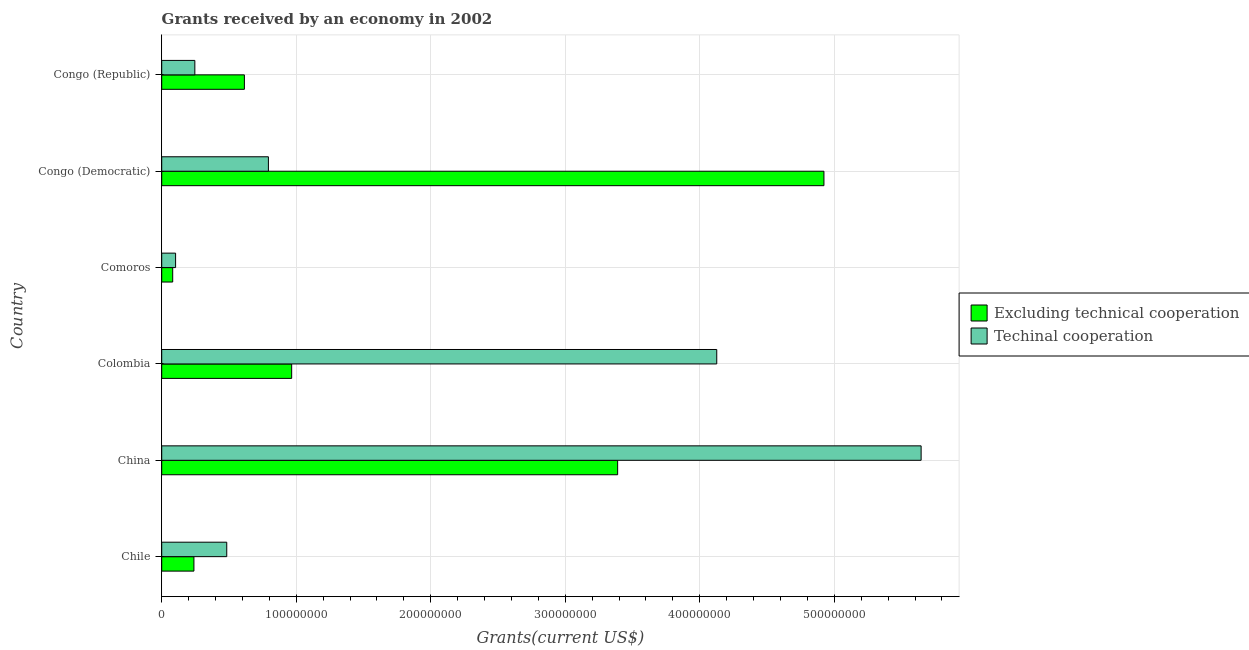How many different coloured bars are there?
Provide a succinct answer. 2. How many bars are there on the 4th tick from the bottom?
Provide a succinct answer. 2. What is the label of the 2nd group of bars from the top?
Make the answer very short. Congo (Democratic). In how many cases, is the number of bars for a given country not equal to the number of legend labels?
Provide a succinct answer. 0. What is the amount of grants received(including technical cooperation) in Congo (Democratic)?
Keep it short and to the point. 7.93e+07. Across all countries, what is the maximum amount of grants received(excluding technical cooperation)?
Your response must be concise. 4.92e+08. Across all countries, what is the minimum amount of grants received(excluding technical cooperation)?
Provide a short and direct response. 8.17e+06. In which country was the amount of grants received(excluding technical cooperation) maximum?
Your answer should be very brief. Congo (Democratic). In which country was the amount of grants received(excluding technical cooperation) minimum?
Offer a terse response. Comoros. What is the total amount of grants received(including technical cooperation) in the graph?
Ensure brevity in your answer.  1.14e+09. What is the difference between the amount of grants received(excluding technical cooperation) in China and that in Colombia?
Offer a terse response. 2.42e+08. What is the difference between the amount of grants received(excluding technical cooperation) in Congo (Democratic) and the amount of grants received(including technical cooperation) in Comoros?
Provide a succinct answer. 4.82e+08. What is the average amount of grants received(including technical cooperation) per country?
Your answer should be very brief. 1.90e+08. What is the difference between the amount of grants received(including technical cooperation) and amount of grants received(excluding technical cooperation) in Chile?
Your answer should be very brief. 2.44e+07. In how many countries, is the amount of grants received(including technical cooperation) greater than 100000000 US$?
Offer a terse response. 2. What is the ratio of the amount of grants received(excluding technical cooperation) in Chile to that in China?
Make the answer very short. 0.07. What is the difference between the highest and the second highest amount of grants received(excluding technical cooperation)?
Keep it short and to the point. 1.53e+08. What is the difference between the highest and the lowest amount of grants received(excluding technical cooperation)?
Keep it short and to the point. 4.84e+08. In how many countries, is the amount of grants received(excluding technical cooperation) greater than the average amount of grants received(excluding technical cooperation) taken over all countries?
Make the answer very short. 2. Is the sum of the amount of grants received(excluding technical cooperation) in Chile and Comoros greater than the maximum amount of grants received(including technical cooperation) across all countries?
Provide a short and direct response. No. What does the 2nd bar from the top in Chile represents?
Provide a succinct answer. Excluding technical cooperation. What does the 1st bar from the bottom in Congo (Democratic) represents?
Keep it short and to the point. Excluding technical cooperation. How many bars are there?
Ensure brevity in your answer.  12. Are all the bars in the graph horizontal?
Your answer should be very brief. Yes. How many countries are there in the graph?
Offer a very short reply. 6. What is the difference between two consecutive major ticks on the X-axis?
Offer a very short reply. 1.00e+08. Does the graph contain grids?
Offer a very short reply. Yes. How are the legend labels stacked?
Your answer should be very brief. Vertical. What is the title of the graph?
Make the answer very short. Grants received by an economy in 2002. What is the label or title of the X-axis?
Your answer should be very brief. Grants(current US$). What is the Grants(current US$) of Excluding technical cooperation in Chile?
Give a very brief answer. 2.40e+07. What is the Grants(current US$) of Techinal cooperation in Chile?
Offer a very short reply. 4.84e+07. What is the Grants(current US$) in Excluding technical cooperation in China?
Ensure brevity in your answer.  3.39e+08. What is the Grants(current US$) of Techinal cooperation in China?
Make the answer very short. 5.65e+08. What is the Grants(current US$) of Excluding technical cooperation in Colombia?
Your answer should be compact. 9.66e+07. What is the Grants(current US$) in Techinal cooperation in Colombia?
Offer a terse response. 4.13e+08. What is the Grants(current US$) in Excluding technical cooperation in Comoros?
Your answer should be compact. 8.17e+06. What is the Grants(current US$) of Techinal cooperation in Comoros?
Give a very brief answer. 1.03e+07. What is the Grants(current US$) in Excluding technical cooperation in Congo (Democratic)?
Offer a very short reply. 4.92e+08. What is the Grants(current US$) in Techinal cooperation in Congo (Democratic)?
Provide a succinct answer. 7.93e+07. What is the Grants(current US$) of Excluding technical cooperation in Congo (Republic)?
Provide a short and direct response. 6.15e+07. What is the Grants(current US$) of Techinal cooperation in Congo (Republic)?
Offer a terse response. 2.46e+07. Across all countries, what is the maximum Grants(current US$) in Excluding technical cooperation?
Provide a short and direct response. 4.92e+08. Across all countries, what is the maximum Grants(current US$) of Techinal cooperation?
Your answer should be very brief. 5.65e+08. Across all countries, what is the minimum Grants(current US$) of Excluding technical cooperation?
Ensure brevity in your answer.  8.17e+06. Across all countries, what is the minimum Grants(current US$) of Techinal cooperation?
Your answer should be compact. 1.03e+07. What is the total Grants(current US$) in Excluding technical cooperation in the graph?
Keep it short and to the point. 1.02e+09. What is the total Grants(current US$) in Techinal cooperation in the graph?
Your response must be concise. 1.14e+09. What is the difference between the Grants(current US$) in Excluding technical cooperation in Chile and that in China?
Give a very brief answer. -3.15e+08. What is the difference between the Grants(current US$) of Techinal cooperation in Chile and that in China?
Your response must be concise. -5.16e+08. What is the difference between the Grants(current US$) of Excluding technical cooperation in Chile and that in Colombia?
Your answer should be compact. -7.27e+07. What is the difference between the Grants(current US$) in Techinal cooperation in Chile and that in Colombia?
Provide a short and direct response. -3.64e+08. What is the difference between the Grants(current US$) in Excluding technical cooperation in Chile and that in Comoros?
Your answer should be very brief. 1.58e+07. What is the difference between the Grants(current US$) of Techinal cooperation in Chile and that in Comoros?
Offer a terse response. 3.80e+07. What is the difference between the Grants(current US$) in Excluding technical cooperation in Chile and that in Congo (Democratic)?
Give a very brief answer. -4.68e+08. What is the difference between the Grants(current US$) of Techinal cooperation in Chile and that in Congo (Democratic)?
Your answer should be very brief. -3.10e+07. What is the difference between the Grants(current US$) in Excluding technical cooperation in Chile and that in Congo (Republic)?
Your response must be concise. -3.75e+07. What is the difference between the Grants(current US$) in Techinal cooperation in Chile and that in Congo (Republic)?
Your answer should be very brief. 2.37e+07. What is the difference between the Grants(current US$) of Excluding technical cooperation in China and that in Colombia?
Your response must be concise. 2.42e+08. What is the difference between the Grants(current US$) in Techinal cooperation in China and that in Colombia?
Offer a terse response. 1.52e+08. What is the difference between the Grants(current US$) of Excluding technical cooperation in China and that in Comoros?
Offer a terse response. 3.31e+08. What is the difference between the Grants(current US$) in Techinal cooperation in China and that in Comoros?
Provide a short and direct response. 5.54e+08. What is the difference between the Grants(current US$) of Excluding technical cooperation in China and that in Congo (Democratic)?
Provide a short and direct response. -1.53e+08. What is the difference between the Grants(current US$) in Techinal cooperation in China and that in Congo (Democratic)?
Offer a terse response. 4.85e+08. What is the difference between the Grants(current US$) in Excluding technical cooperation in China and that in Congo (Republic)?
Keep it short and to the point. 2.77e+08. What is the difference between the Grants(current US$) in Techinal cooperation in China and that in Congo (Republic)?
Your answer should be compact. 5.40e+08. What is the difference between the Grants(current US$) of Excluding technical cooperation in Colombia and that in Comoros?
Your response must be concise. 8.84e+07. What is the difference between the Grants(current US$) of Techinal cooperation in Colombia and that in Comoros?
Keep it short and to the point. 4.02e+08. What is the difference between the Grants(current US$) in Excluding technical cooperation in Colombia and that in Congo (Democratic)?
Offer a terse response. -3.96e+08. What is the difference between the Grants(current US$) of Techinal cooperation in Colombia and that in Congo (Democratic)?
Provide a short and direct response. 3.33e+08. What is the difference between the Grants(current US$) in Excluding technical cooperation in Colombia and that in Congo (Republic)?
Provide a succinct answer. 3.52e+07. What is the difference between the Grants(current US$) in Techinal cooperation in Colombia and that in Congo (Republic)?
Your answer should be very brief. 3.88e+08. What is the difference between the Grants(current US$) of Excluding technical cooperation in Comoros and that in Congo (Democratic)?
Ensure brevity in your answer.  -4.84e+08. What is the difference between the Grants(current US$) in Techinal cooperation in Comoros and that in Congo (Democratic)?
Make the answer very short. -6.90e+07. What is the difference between the Grants(current US$) of Excluding technical cooperation in Comoros and that in Congo (Republic)?
Your response must be concise. -5.33e+07. What is the difference between the Grants(current US$) of Techinal cooperation in Comoros and that in Congo (Republic)?
Ensure brevity in your answer.  -1.43e+07. What is the difference between the Grants(current US$) of Excluding technical cooperation in Congo (Democratic) and that in Congo (Republic)?
Your answer should be compact. 4.31e+08. What is the difference between the Grants(current US$) in Techinal cooperation in Congo (Democratic) and that in Congo (Republic)?
Give a very brief answer. 5.47e+07. What is the difference between the Grants(current US$) in Excluding technical cooperation in Chile and the Grants(current US$) in Techinal cooperation in China?
Offer a terse response. -5.41e+08. What is the difference between the Grants(current US$) in Excluding technical cooperation in Chile and the Grants(current US$) in Techinal cooperation in Colombia?
Offer a very short reply. -3.89e+08. What is the difference between the Grants(current US$) of Excluding technical cooperation in Chile and the Grants(current US$) of Techinal cooperation in Comoros?
Your answer should be compact. 1.36e+07. What is the difference between the Grants(current US$) in Excluding technical cooperation in Chile and the Grants(current US$) in Techinal cooperation in Congo (Democratic)?
Provide a short and direct response. -5.54e+07. What is the difference between the Grants(current US$) in Excluding technical cooperation in Chile and the Grants(current US$) in Techinal cooperation in Congo (Republic)?
Give a very brief answer. -6.80e+05. What is the difference between the Grants(current US$) of Excluding technical cooperation in China and the Grants(current US$) of Techinal cooperation in Colombia?
Provide a succinct answer. -7.37e+07. What is the difference between the Grants(current US$) in Excluding technical cooperation in China and the Grants(current US$) in Techinal cooperation in Comoros?
Provide a succinct answer. 3.29e+08. What is the difference between the Grants(current US$) of Excluding technical cooperation in China and the Grants(current US$) of Techinal cooperation in Congo (Democratic)?
Offer a terse response. 2.60e+08. What is the difference between the Grants(current US$) of Excluding technical cooperation in China and the Grants(current US$) of Techinal cooperation in Congo (Republic)?
Your answer should be very brief. 3.14e+08. What is the difference between the Grants(current US$) in Excluding technical cooperation in Colombia and the Grants(current US$) in Techinal cooperation in Comoros?
Provide a short and direct response. 8.63e+07. What is the difference between the Grants(current US$) of Excluding technical cooperation in Colombia and the Grants(current US$) of Techinal cooperation in Congo (Democratic)?
Your response must be concise. 1.73e+07. What is the difference between the Grants(current US$) of Excluding technical cooperation in Colombia and the Grants(current US$) of Techinal cooperation in Congo (Republic)?
Give a very brief answer. 7.20e+07. What is the difference between the Grants(current US$) of Excluding technical cooperation in Comoros and the Grants(current US$) of Techinal cooperation in Congo (Democratic)?
Ensure brevity in your answer.  -7.11e+07. What is the difference between the Grants(current US$) in Excluding technical cooperation in Comoros and the Grants(current US$) in Techinal cooperation in Congo (Republic)?
Ensure brevity in your answer.  -1.65e+07. What is the difference between the Grants(current US$) of Excluding technical cooperation in Congo (Democratic) and the Grants(current US$) of Techinal cooperation in Congo (Republic)?
Your response must be concise. 4.68e+08. What is the average Grants(current US$) of Excluding technical cooperation per country?
Provide a short and direct response. 1.70e+08. What is the average Grants(current US$) of Techinal cooperation per country?
Keep it short and to the point. 1.90e+08. What is the difference between the Grants(current US$) in Excluding technical cooperation and Grants(current US$) in Techinal cooperation in Chile?
Your answer should be compact. -2.44e+07. What is the difference between the Grants(current US$) of Excluding technical cooperation and Grants(current US$) of Techinal cooperation in China?
Offer a very short reply. -2.26e+08. What is the difference between the Grants(current US$) of Excluding technical cooperation and Grants(current US$) of Techinal cooperation in Colombia?
Offer a terse response. -3.16e+08. What is the difference between the Grants(current US$) of Excluding technical cooperation and Grants(current US$) of Techinal cooperation in Comoros?
Offer a terse response. -2.15e+06. What is the difference between the Grants(current US$) in Excluding technical cooperation and Grants(current US$) in Techinal cooperation in Congo (Democratic)?
Your answer should be very brief. 4.13e+08. What is the difference between the Grants(current US$) in Excluding technical cooperation and Grants(current US$) in Techinal cooperation in Congo (Republic)?
Offer a very short reply. 3.68e+07. What is the ratio of the Grants(current US$) in Excluding technical cooperation in Chile to that in China?
Make the answer very short. 0.07. What is the ratio of the Grants(current US$) of Techinal cooperation in Chile to that in China?
Ensure brevity in your answer.  0.09. What is the ratio of the Grants(current US$) in Excluding technical cooperation in Chile to that in Colombia?
Ensure brevity in your answer.  0.25. What is the ratio of the Grants(current US$) in Techinal cooperation in Chile to that in Colombia?
Keep it short and to the point. 0.12. What is the ratio of the Grants(current US$) of Excluding technical cooperation in Chile to that in Comoros?
Offer a very short reply. 2.93. What is the ratio of the Grants(current US$) of Techinal cooperation in Chile to that in Comoros?
Give a very brief answer. 4.69. What is the ratio of the Grants(current US$) of Excluding technical cooperation in Chile to that in Congo (Democratic)?
Your response must be concise. 0.05. What is the ratio of the Grants(current US$) in Techinal cooperation in Chile to that in Congo (Democratic)?
Your answer should be very brief. 0.61. What is the ratio of the Grants(current US$) of Excluding technical cooperation in Chile to that in Congo (Republic)?
Your answer should be very brief. 0.39. What is the ratio of the Grants(current US$) in Techinal cooperation in Chile to that in Congo (Republic)?
Provide a succinct answer. 1.96. What is the ratio of the Grants(current US$) of Excluding technical cooperation in China to that in Colombia?
Offer a very short reply. 3.51. What is the ratio of the Grants(current US$) of Techinal cooperation in China to that in Colombia?
Provide a short and direct response. 1.37. What is the ratio of the Grants(current US$) of Excluding technical cooperation in China to that in Comoros?
Make the answer very short. 41.48. What is the ratio of the Grants(current US$) of Techinal cooperation in China to that in Comoros?
Your answer should be compact. 54.7. What is the ratio of the Grants(current US$) of Excluding technical cooperation in China to that in Congo (Democratic)?
Provide a short and direct response. 0.69. What is the ratio of the Grants(current US$) in Techinal cooperation in China to that in Congo (Democratic)?
Provide a succinct answer. 7.12. What is the ratio of the Grants(current US$) of Excluding technical cooperation in China to that in Congo (Republic)?
Offer a terse response. 5.51. What is the ratio of the Grants(current US$) in Techinal cooperation in China to that in Congo (Republic)?
Your answer should be compact. 22.92. What is the ratio of the Grants(current US$) of Excluding technical cooperation in Colombia to that in Comoros?
Your answer should be very brief. 11.82. What is the ratio of the Grants(current US$) in Techinal cooperation in Colombia to that in Comoros?
Your answer should be very brief. 39.98. What is the ratio of the Grants(current US$) of Excluding technical cooperation in Colombia to that in Congo (Democratic)?
Provide a short and direct response. 0.2. What is the ratio of the Grants(current US$) of Techinal cooperation in Colombia to that in Congo (Democratic)?
Make the answer very short. 5.2. What is the ratio of the Grants(current US$) in Excluding technical cooperation in Colombia to that in Congo (Republic)?
Your answer should be very brief. 1.57. What is the ratio of the Grants(current US$) in Techinal cooperation in Colombia to that in Congo (Republic)?
Your answer should be compact. 16.75. What is the ratio of the Grants(current US$) in Excluding technical cooperation in Comoros to that in Congo (Democratic)?
Offer a terse response. 0.02. What is the ratio of the Grants(current US$) of Techinal cooperation in Comoros to that in Congo (Democratic)?
Provide a short and direct response. 0.13. What is the ratio of the Grants(current US$) in Excluding technical cooperation in Comoros to that in Congo (Republic)?
Your response must be concise. 0.13. What is the ratio of the Grants(current US$) in Techinal cooperation in Comoros to that in Congo (Republic)?
Make the answer very short. 0.42. What is the ratio of the Grants(current US$) of Excluding technical cooperation in Congo (Democratic) to that in Congo (Republic)?
Ensure brevity in your answer.  8.01. What is the ratio of the Grants(current US$) of Techinal cooperation in Congo (Democratic) to that in Congo (Republic)?
Provide a short and direct response. 3.22. What is the difference between the highest and the second highest Grants(current US$) of Excluding technical cooperation?
Give a very brief answer. 1.53e+08. What is the difference between the highest and the second highest Grants(current US$) of Techinal cooperation?
Your response must be concise. 1.52e+08. What is the difference between the highest and the lowest Grants(current US$) of Excluding technical cooperation?
Provide a short and direct response. 4.84e+08. What is the difference between the highest and the lowest Grants(current US$) of Techinal cooperation?
Your answer should be very brief. 5.54e+08. 